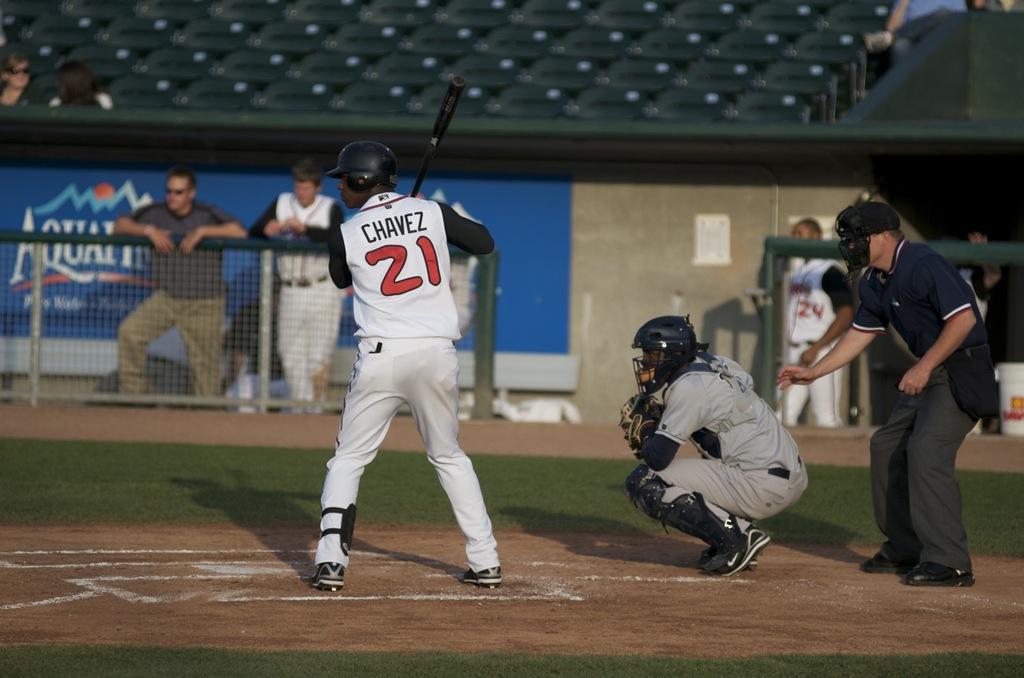What is the name of the batter?
Keep it short and to the point. Chavez. Who water company is being advertised?
Offer a terse response. Aquafina. 